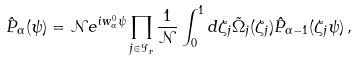Convert formula to latex. <formula><loc_0><loc_0><loc_500><loc_500>\hat { P } _ { \alpha } ( \psi ) = { \mathcal { N } } e ^ { i w _ { \alpha } ^ { 0 } \psi } \prod _ { j \in { \mathcal { I } } _ { r } } \frac { 1 } { { \mathcal { N } } } \int _ { 0 } ^ { 1 } d \zeta _ { j } \tilde { \Omega } _ { j } ( \zeta _ { j } ) \hat { P } _ { \alpha - 1 } ( \zeta _ { j } \psi ) \, ,</formula> 